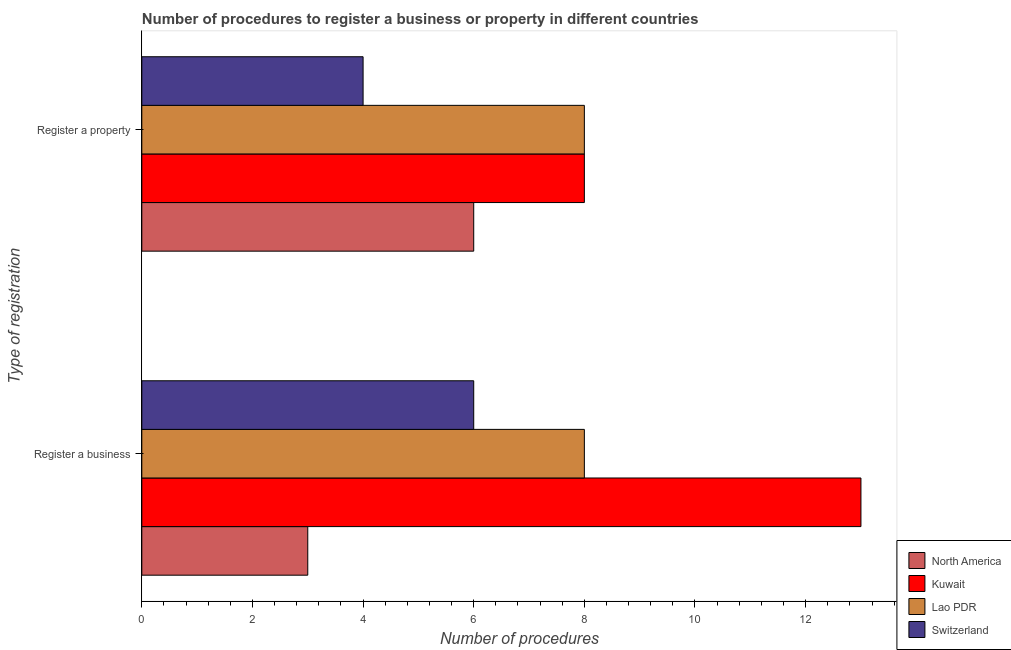How many different coloured bars are there?
Keep it short and to the point. 4. How many groups of bars are there?
Provide a short and direct response. 2. Are the number of bars per tick equal to the number of legend labels?
Provide a succinct answer. Yes. Are the number of bars on each tick of the Y-axis equal?
Keep it short and to the point. Yes. How many bars are there on the 2nd tick from the bottom?
Your answer should be very brief. 4. What is the label of the 1st group of bars from the top?
Provide a succinct answer. Register a property. What is the number of procedures to register a property in North America?
Keep it short and to the point. 6. Across all countries, what is the maximum number of procedures to register a business?
Provide a succinct answer. 13. Across all countries, what is the minimum number of procedures to register a business?
Give a very brief answer. 3. In which country was the number of procedures to register a business maximum?
Offer a terse response. Kuwait. In which country was the number of procedures to register a property minimum?
Offer a very short reply. Switzerland. What is the total number of procedures to register a business in the graph?
Ensure brevity in your answer.  30. What is the difference between the number of procedures to register a business in North America and that in Lao PDR?
Ensure brevity in your answer.  -5. What is the difference between the number of procedures to register a property in Switzerland and the number of procedures to register a business in North America?
Your answer should be very brief. 1. What is the average number of procedures to register a property per country?
Offer a very short reply. 6.5. What is the difference between the number of procedures to register a property and number of procedures to register a business in North America?
Offer a terse response. 3. In how many countries, is the number of procedures to register a business greater than 7.6 ?
Make the answer very short. 2. What does the 3rd bar from the bottom in Register a business represents?
Your response must be concise. Lao PDR. How many bars are there?
Your response must be concise. 8. Are all the bars in the graph horizontal?
Provide a short and direct response. Yes. Are the values on the major ticks of X-axis written in scientific E-notation?
Provide a succinct answer. No. Does the graph contain grids?
Provide a short and direct response. No. Where does the legend appear in the graph?
Provide a succinct answer. Bottom right. How many legend labels are there?
Your response must be concise. 4. How are the legend labels stacked?
Give a very brief answer. Vertical. What is the title of the graph?
Keep it short and to the point. Number of procedures to register a business or property in different countries. What is the label or title of the X-axis?
Your response must be concise. Number of procedures. What is the label or title of the Y-axis?
Provide a short and direct response. Type of registration. What is the Number of procedures in Kuwait in Register a business?
Offer a terse response. 13. What is the Number of procedures of Lao PDR in Register a business?
Provide a short and direct response. 8. What is the Number of procedures of Switzerland in Register a business?
Make the answer very short. 6. What is the Number of procedures of Lao PDR in Register a property?
Your answer should be very brief. 8. What is the Number of procedures of Switzerland in Register a property?
Your response must be concise. 4. Across all Type of registration, what is the maximum Number of procedures of North America?
Your response must be concise. 6. Across all Type of registration, what is the maximum Number of procedures of Kuwait?
Offer a terse response. 13. Across all Type of registration, what is the minimum Number of procedures in Switzerland?
Give a very brief answer. 4. What is the total Number of procedures in Lao PDR in the graph?
Your answer should be compact. 16. What is the total Number of procedures of Switzerland in the graph?
Your answer should be compact. 10. What is the difference between the Number of procedures in Kuwait in Register a business and that in Register a property?
Your response must be concise. 5. What is the difference between the Number of procedures in Lao PDR in Register a business and that in Register a property?
Make the answer very short. 0. What is the difference between the Number of procedures of Switzerland in Register a business and that in Register a property?
Your answer should be compact. 2. What is the difference between the Number of procedures in North America in Register a business and the Number of procedures in Lao PDR in Register a property?
Give a very brief answer. -5. What is the difference between the Number of procedures of Kuwait in Register a business and the Number of procedures of Lao PDR in Register a property?
Keep it short and to the point. 5. What is the difference between the Number of procedures of Kuwait in Register a business and the Number of procedures of Switzerland in Register a property?
Your answer should be compact. 9. What is the average Number of procedures in North America per Type of registration?
Your response must be concise. 4.5. What is the average Number of procedures of Kuwait per Type of registration?
Keep it short and to the point. 10.5. What is the average Number of procedures of Switzerland per Type of registration?
Keep it short and to the point. 5. What is the difference between the Number of procedures of North America and Number of procedures of Kuwait in Register a business?
Provide a succinct answer. -10. What is the difference between the Number of procedures in North America and Number of procedures in Lao PDR in Register a business?
Your answer should be very brief. -5. What is the difference between the Number of procedures in Kuwait and Number of procedures in Lao PDR in Register a business?
Provide a succinct answer. 5. What is the difference between the Number of procedures in Kuwait and Number of procedures in Switzerland in Register a business?
Your answer should be very brief. 7. What is the difference between the Number of procedures in North America and Number of procedures in Lao PDR in Register a property?
Give a very brief answer. -2. What is the difference between the Number of procedures of Kuwait and Number of procedures of Lao PDR in Register a property?
Offer a terse response. 0. What is the ratio of the Number of procedures in North America in Register a business to that in Register a property?
Make the answer very short. 0.5. What is the ratio of the Number of procedures of Kuwait in Register a business to that in Register a property?
Your response must be concise. 1.62. What is the ratio of the Number of procedures in Switzerland in Register a business to that in Register a property?
Provide a short and direct response. 1.5. What is the difference between the highest and the second highest Number of procedures in Kuwait?
Your response must be concise. 5. What is the difference between the highest and the second highest Number of procedures of Lao PDR?
Provide a short and direct response. 0. What is the difference between the highest and the lowest Number of procedures in North America?
Give a very brief answer. 3. What is the difference between the highest and the lowest Number of procedures of Switzerland?
Your answer should be very brief. 2. 